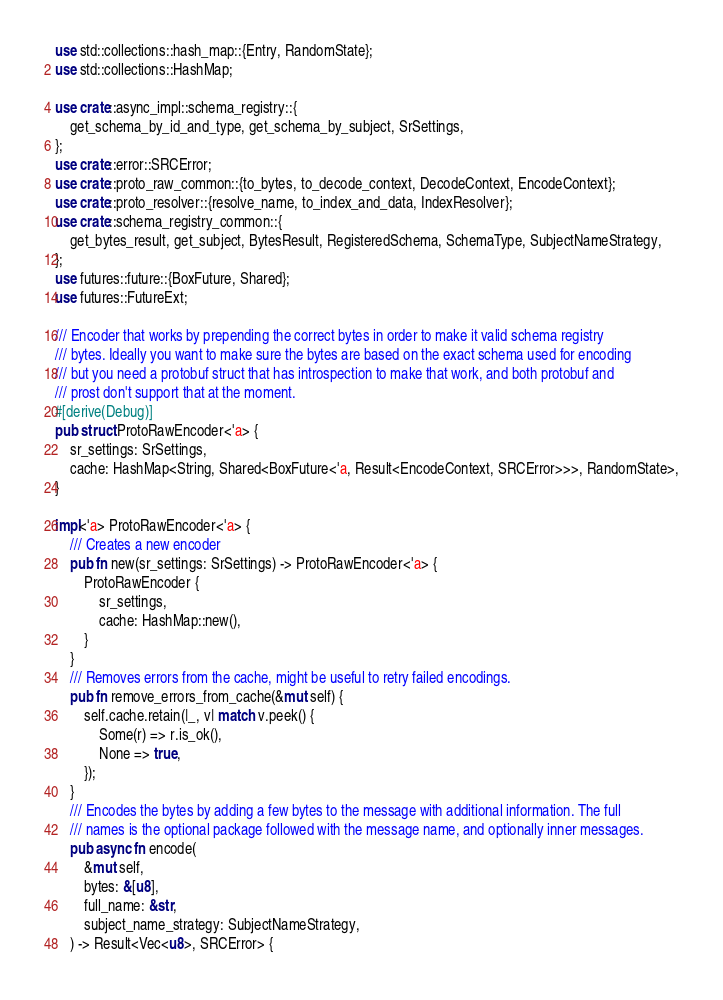Convert code to text. <code><loc_0><loc_0><loc_500><loc_500><_Rust_>use std::collections::hash_map::{Entry, RandomState};
use std::collections::HashMap;

use crate::async_impl::schema_registry::{
    get_schema_by_id_and_type, get_schema_by_subject, SrSettings,
};
use crate::error::SRCError;
use crate::proto_raw_common::{to_bytes, to_decode_context, DecodeContext, EncodeContext};
use crate::proto_resolver::{resolve_name, to_index_and_data, IndexResolver};
use crate::schema_registry_common::{
    get_bytes_result, get_subject, BytesResult, RegisteredSchema, SchemaType, SubjectNameStrategy,
};
use futures::future::{BoxFuture, Shared};
use futures::FutureExt;

/// Encoder that works by prepending the correct bytes in order to make it valid schema registry
/// bytes. Ideally you want to make sure the bytes are based on the exact schema used for encoding
/// but you need a protobuf struct that has introspection to make that work, and both protobuf and
/// prost don't support that at the moment.
#[derive(Debug)]
pub struct ProtoRawEncoder<'a> {
    sr_settings: SrSettings,
    cache: HashMap<String, Shared<BoxFuture<'a, Result<EncodeContext, SRCError>>>, RandomState>,
}

impl<'a> ProtoRawEncoder<'a> {
    /// Creates a new encoder
    pub fn new(sr_settings: SrSettings) -> ProtoRawEncoder<'a> {
        ProtoRawEncoder {
            sr_settings,
            cache: HashMap::new(),
        }
    }
    /// Removes errors from the cache, might be useful to retry failed encodings.
    pub fn remove_errors_from_cache(&mut self) {
        self.cache.retain(|_, v| match v.peek() {
            Some(r) => r.is_ok(),
            None => true,
        });
    }
    /// Encodes the bytes by adding a few bytes to the message with additional information. The full
    /// names is the optional package followed with the message name, and optionally inner messages.
    pub async fn encode(
        &mut self,
        bytes: &[u8],
        full_name: &str,
        subject_name_strategy: SubjectNameStrategy,
    ) -> Result<Vec<u8>, SRCError> {</code> 